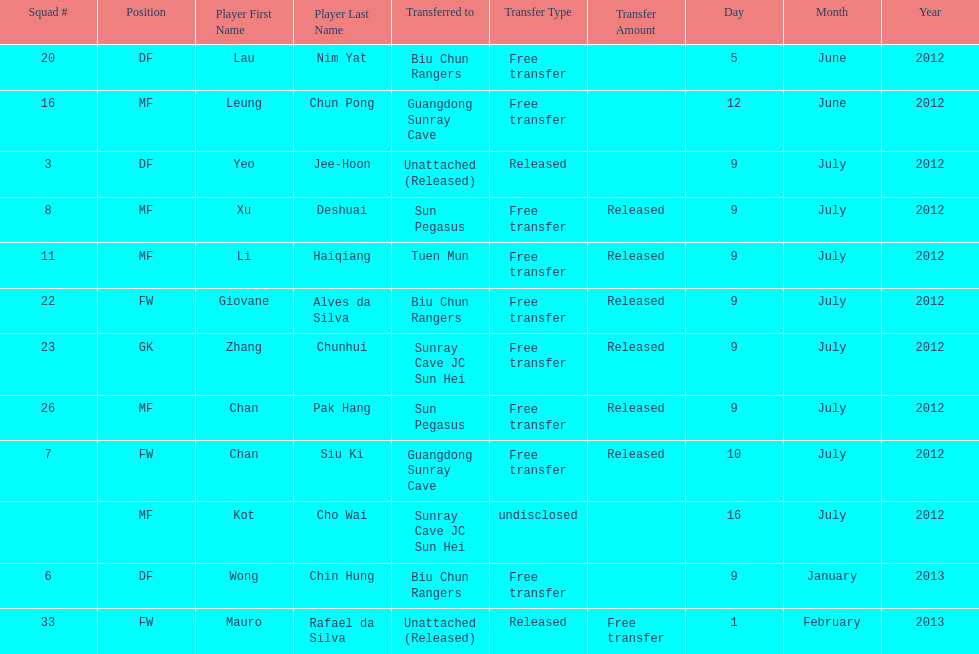Parse the table in full. {'header': ['Squad #', 'Position', 'Player First Name', 'Player Last Name', 'Transferred to', 'Transfer Type', 'Transfer Amount', 'Day', 'Month', 'Year'], 'rows': [['20', 'DF', 'Lau', 'Nim Yat', 'Biu Chun Rangers', 'Free transfer', '', '5', 'June', '2012'], ['16', 'MF', 'Leung', 'Chun Pong', 'Guangdong Sunray Cave', 'Free transfer', '', '12', 'June', '2012'], ['3', 'DF', 'Yeo', 'Jee-Hoon', 'Unattached (Released)', 'Released', '', '9', 'July', '2012'], ['8', 'MF', 'Xu', 'Deshuai', 'Sun Pegasus', 'Free transfer', 'Released', '9', 'July', '2012'], ['11', 'MF', 'Li', 'Haiqiang', 'Tuen Mun', 'Free transfer', 'Released', '9', 'July', '2012'], ['22', 'FW', 'Giovane', 'Alves da Silva', 'Biu Chun Rangers', 'Free transfer', 'Released', '9', 'July', '2012'], ['23', 'GK', 'Zhang', 'Chunhui', 'Sunray Cave JC Sun Hei', 'Free transfer', 'Released', '9', 'July', '2012'], ['26', 'MF', 'Chan', 'Pak Hang', 'Sun Pegasus', 'Free transfer', 'Released', '9', 'July', '2012'], ['7', 'FW', 'Chan', 'Siu Ki', 'Guangdong Sunray Cave', 'Free transfer', 'Released', '10', 'July', '2012'], ['', 'MF', 'Kot', 'Cho Wai', 'Sunray Cave JC Sun Hei', 'undisclosed', '', '16', 'July', '2012'], ['6', 'DF', 'Wong', 'Chin Hung', 'Biu Chun Rangers', 'Free transfer', '', '9', 'January', '2013'], ['33', 'FW', 'Mauro', 'Rafael da Silva', 'Unattached (Released)', 'Released', 'Free transfer', '1', 'February', '2013']]} Lau nim yat and giovane alves de silva where both transferred to which team? Biu Chun Rangers. 